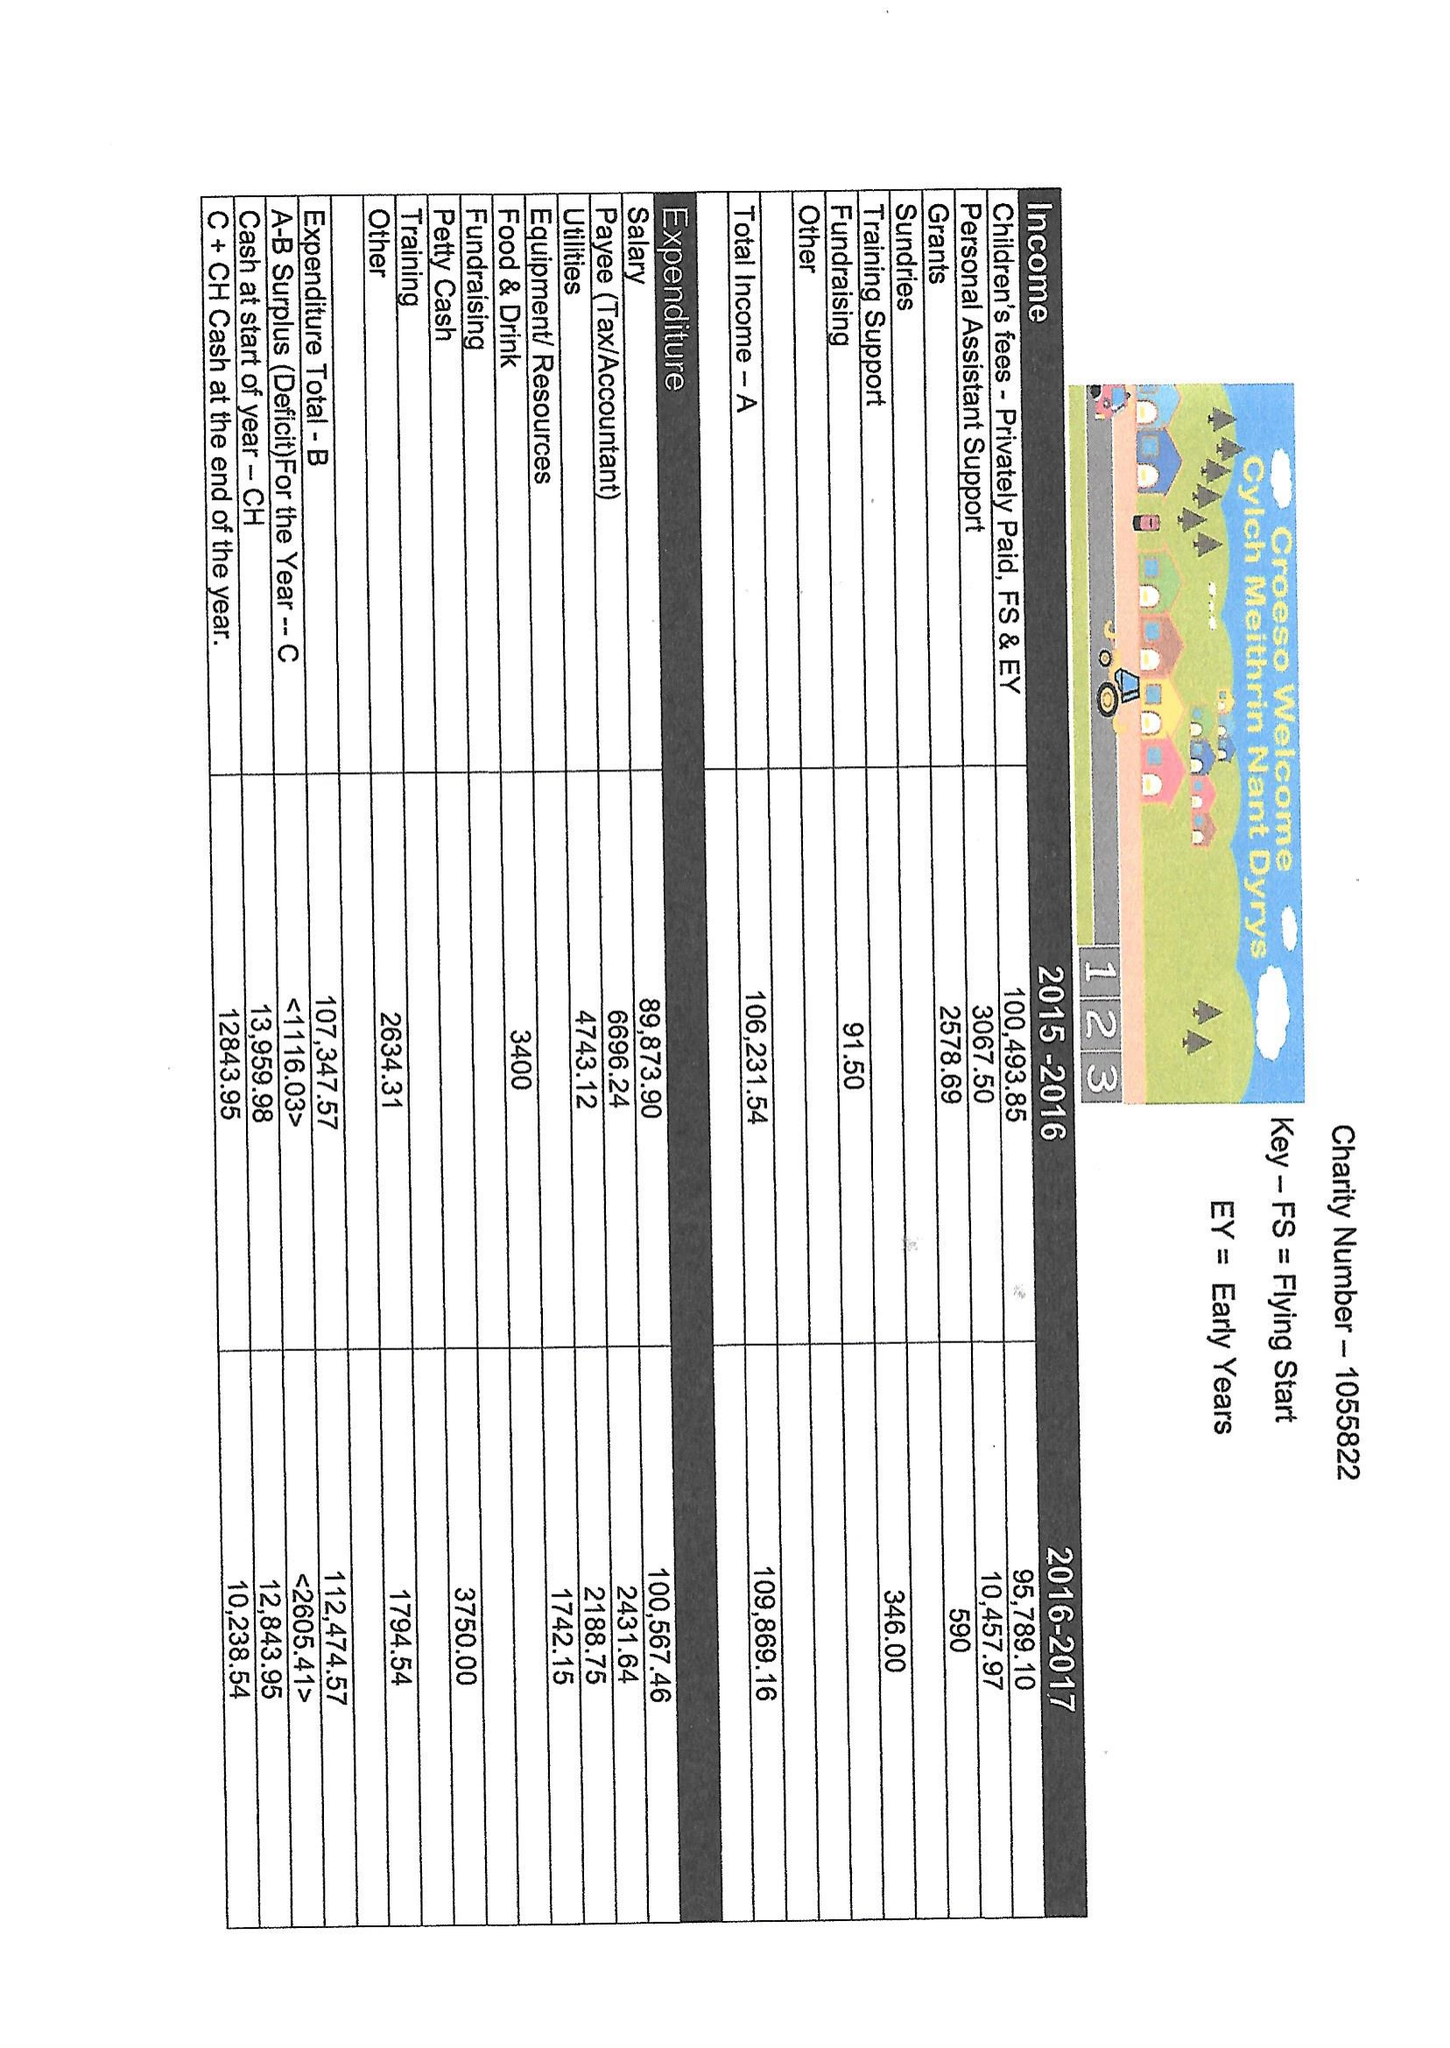What is the value for the address__post_town?
Answer the question using a single word or phrase. TREORCHY 